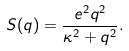<formula> <loc_0><loc_0><loc_500><loc_500>S ( q ) = \frac { e ^ { 2 } q ^ { 2 } } { \kappa ^ { 2 } + q ^ { 2 } } .</formula> 